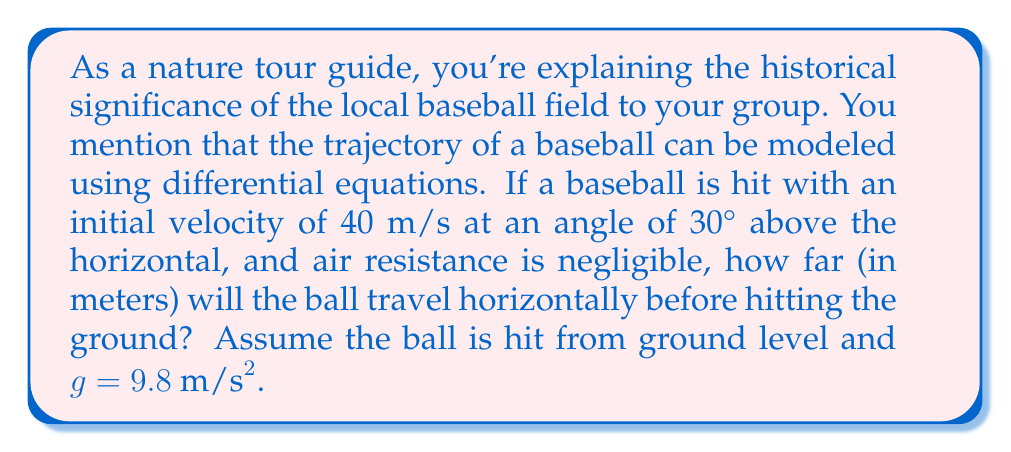Teach me how to tackle this problem. Let's approach this problem step-by-step using differential equations:

1) First, we need to set up our coordinate system. Let's use $x$ for horizontal distance and $y$ for vertical distance.

2) The motion of the ball can be described by two second-order differential equations:

   $$\frac{d^2x}{dt^2} = 0$$
   $$\frac{d^2y}{dt^2} = -g$$

3) Integrating these equations once gives us:

   $$\frac{dx}{dt} = v_0 \cos \theta$$
   $$\frac{dy}{dt} = v_0 \sin \theta - gt$$

   Where $v_0$ is the initial velocity and $\theta$ is the launch angle.

4) Integrating again:

   $$x = (v_0 \cos \theta)t$$
   $$y = (v_0 \sin \theta)t - \frac{1}{2}gt^2$$

5) We're given $v_0 = 40 \text{ m/s}$, $\theta = 30°$, and $g = 9.8 \text{ m/s}^2$.

6) To find the horizontal distance, we need to find the time when the ball hits the ground, i.e., when $y = 0$:

   $$0 = (40 \sin 30°)t - \frac{1}{2}(9.8)t^2$$

7) Solving this quadratic equation:

   $$t = \frac{2(40 \sin 30°)}{9.8} = 4.08 \text{ seconds}$$

8) Now we can plug this time into the equation for $x$:

   $$x = (40 \cos 30°)(4.08) = 141.37 \text{ meters}$$

Thus, the ball will travel approximately 141.37 meters horizontally before hitting the ground.
Answer: 141.37 meters 